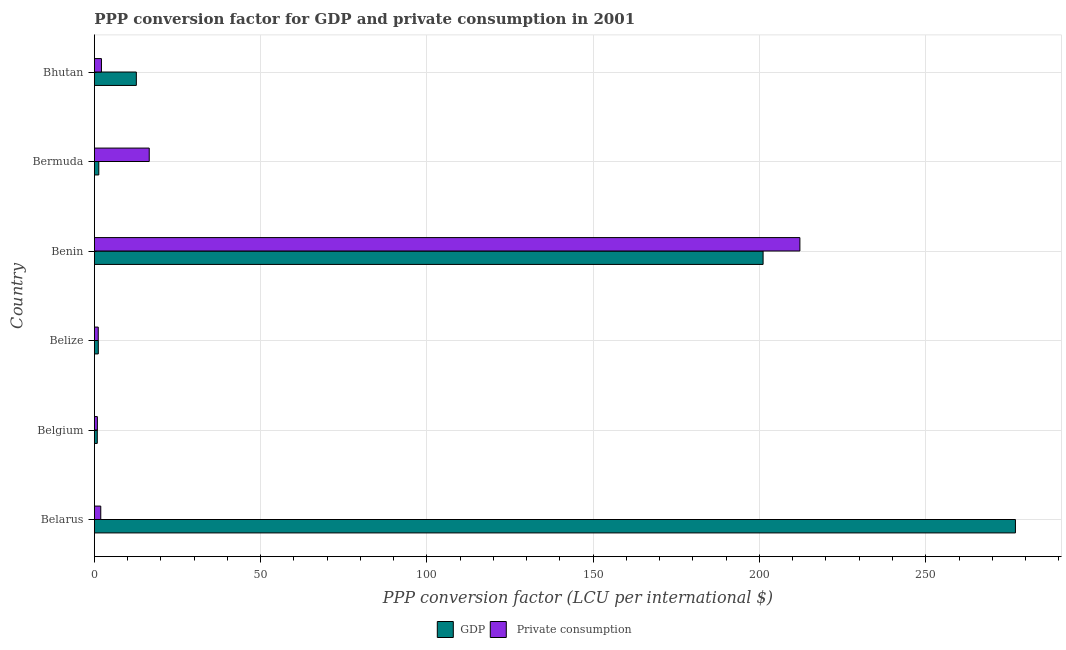How many different coloured bars are there?
Your response must be concise. 2. How many groups of bars are there?
Keep it short and to the point. 6. Are the number of bars on each tick of the Y-axis equal?
Your response must be concise. Yes. In how many cases, is the number of bars for a given country not equal to the number of legend labels?
Your answer should be very brief. 0. What is the ppp conversion factor for gdp in Belize?
Provide a short and direct response. 1.19. Across all countries, what is the maximum ppp conversion factor for gdp?
Make the answer very short. 276.97. Across all countries, what is the minimum ppp conversion factor for gdp?
Give a very brief answer. 0.89. In which country was the ppp conversion factor for gdp maximum?
Ensure brevity in your answer.  Belarus. What is the total ppp conversion factor for gdp in the graph?
Offer a terse response. 494.1. What is the difference between the ppp conversion factor for private consumption in Belarus and that in Belize?
Give a very brief answer. 0.76. What is the difference between the ppp conversion factor for private consumption in Bhutan and the ppp conversion factor for gdp in Belize?
Make the answer very short. 0.95. What is the average ppp conversion factor for private consumption per country?
Make the answer very short. 39.14. What is the difference between the ppp conversion factor for gdp and ppp conversion factor for private consumption in Belize?
Ensure brevity in your answer.  0.01. In how many countries, is the ppp conversion factor for private consumption greater than 140 LCU?
Your answer should be compact. 1. What is the ratio of the ppp conversion factor for private consumption in Belize to that in Bermuda?
Ensure brevity in your answer.  0.07. Is the ppp conversion factor for gdp in Belarus less than that in Benin?
Your response must be concise. No. What is the difference between the highest and the second highest ppp conversion factor for gdp?
Ensure brevity in your answer.  75.88. What is the difference between the highest and the lowest ppp conversion factor for gdp?
Provide a short and direct response. 276.08. What does the 1st bar from the top in Bermuda represents?
Make the answer very short.  Private consumption. What does the 2nd bar from the bottom in Bhutan represents?
Keep it short and to the point.  Private consumption. Are all the bars in the graph horizontal?
Provide a short and direct response. Yes. What is the difference between two consecutive major ticks on the X-axis?
Keep it short and to the point. 50. Are the values on the major ticks of X-axis written in scientific E-notation?
Ensure brevity in your answer.  No. Does the graph contain any zero values?
Your answer should be compact. No. How are the legend labels stacked?
Your response must be concise. Horizontal. What is the title of the graph?
Keep it short and to the point. PPP conversion factor for GDP and private consumption in 2001. Does "GDP" appear as one of the legend labels in the graph?
Provide a succinct answer. Yes. What is the label or title of the X-axis?
Make the answer very short. PPP conversion factor (LCU per international $). What is the PPP conversion factor (LCU per international $) in GDP in Belarus?
Give a very brief answer. 276.97. What is the PPP conversion factor (LCU per international $) in  Private consumption in Belarus?
Provide a succinct answer. 1.93. What is the PPP conversion factor (LCU per international $) in GDP in Belgium?
Provide a succinct answer. 0.89. What is the PPP conversion factor (LCU per international $) of  Private consumption in Belgium?
Make the answer very short. 0.91. What is the PPP conversion factor (LCU per international $) in GDP in Belize?
Your answer should be very brief. 1.19. What is the PPP conversion factor (LCU per international $) of  Private consumption in Belize?
Offer a terse response. 1.17. What is the PPP conversion factor (LCU per international $) in GDP in Benin?
Your answer should be compact. 201.09. What is the PPP conversion factor (LCU per international $) in  Private consumption in Benin?
Your answer should be compact. 212.16. What is the PPP conversion factor (LCU per international $) in GDP in Bermuda?
Give a very brief answer. 1.34. What is the PPP conversion factor (LCU per international $) in  Private consumption in Bermuda?
Give a very brief answer. 16.51. What is the PPP conversion factor (LCU per international $) of GDP in Bhutan?
Ensure brevity in your answer.  12.63. What is the PPP conversion factor (LCU per international $) in  Private consumption in Bhutan?
Ensure brevity in your answer.  2.14. Across all countries, what is the maximum PPP conversion factor (LCU per international $) of GDP?
Keep it short and to the point. 276.97. Across all countries, what is the maximum PPP conversion factor (LCU per international $) of  Private consumption?
Provide a succinct answer. 212.16. Across all countries, what is the minimum PPP conversion factor (LCU per international $) of GDP?
Provide a succinct answer. 0.89. Across all countries, what is the minimum PPP conversion factor (LCU per international $) of  Private consumption?
Provide a short and direct response. 0.91. What is the total PPP conversion factor (LCU per international $) in GDP in the graph?
Ensure brevity in your answer.  494.1. What is the total PPP conversion factor (LCU per international $) in  Private consumption in the graph?
Keep it short and to the point. 234.82. What is the difference between the PPP conversion factor (LCU per international $) in GDP in Belarus and that in Belgium?
Keep it short and to the point. 276.08. What is the difference between the PPP conversion factor (LCU per international $) in  Private consumption in Belarus and that in Belgium?
Offer a terse response. 1.02. What is the difference between the PPP conversion factor (LCU per international $) in GDP in Belarus and that in Belize?
Offer a very short reply. 275.78. What is the difference between the PPP conversion factor (LCU per international $) in  Private consumption in Belarus and that in Belize?
Ensure brevity in your answer.  0.76. What is the difference between the PPP conversion factor (LCU per international $) in GDP in Belarus and that in Benin?
Provide a short and direct response. 75.88. What is the difference between the PPP conversion factor (LCU per international $) in  Private consumption in Belarus and that in Benin?
Your answer should be compact. -210.22. What is the difference between the PPP conversion factor (LCU per international $) of GDP in Belarus and that in Bermuda?
Offer a terse response. 275.63. What is the difference between the PPP conversion factor (LCU per international $) in  Private consumption in Belarus and that in Bermuda?
Keep it short and to the point. -14.57. What is the difference between the PPP conversion factor (LCU per international $) of GDP in Belarus and that in Bhutan?
Your response must be concise. 264.34. What is the difference between the PPP conversion factor (LCU per international $) of  Private consumption in Belarus and that in Bhutan?
Ensure brevity in your answer.  -0.21. What is the difference between the PPP conversion factor (LCU per international $) in GDP in Belgium and that in Belize?
Your response must be concise. -0.3. What is the difference between the PPP conversion factor (LCU per international $) in  Private consumption in Belgium and that in Belize?
Provide a short and direct response. -0.26. What is the difference between the PPP conversion factor (LCU per international $) in GDP in Belgium and that in Benin?
Your answer should be very brief. -200.2. What is the difference between the PPP conversion factor (LCU per international $) in  Private consumption in Belgium and that in Benin?
Your response must be concise. -211.24. What is the difference between the PPP conversion factor (LCU per international $) of GDP in Belgium and that in Bermuda?
Ensure brevity in your answer.  -0.45. What is the difference between the PPP conversion factor (LCU per international $) of  Private consumption in Belgium and that in Bermuda?
Provide a succinct answer. -15.59. What is the difference between the PPP conversion factor (LCU per international $) of GDP in Belgium and that in Bhutan?
Keep it short and to the point. -11.74. What is the difference between the PPP conversion factor (LCU per international $) of  Private consumption in Belgium and that in Bhutan?
Your answer should be compact. -1.23. What is the difference between the PPP conversion factor (LCU per international $) in GDP in Belize and that in Benin?
Offer a very short reply. -199.9. What is the difference between the PPP conversion factor (LCU per international $) of  Private consumption in Belize and that in Benin?
Offer a terse response. -210.98. What is the difference between the PPP conversion factor (LCU per international $) of GDP in Belize and that in Bermuda?
Make the answer very short. -0.15. What is the difference between the PPP conversion factor (LCU per international $) in  Private consumption in Belize and that in Bermuda?
Ensure brevity in your answer.  -15.33. What is the difference between the PPP conversion factor (LCU per international $) in GDP in Belize and that in Bhutan?
Make the answer very short. -11.44. What is the difference between the PPP conversion factor (LCU per international $) in  Private consumption in Belize and that in Bhutan?
Make the answer very short. -0.96. What is the difference between the PPP conversion factor (LCU per international $) of GDP in Benin and that in Bermuda?
Keep it short and to the point. 199.75. What is the difference between the PPP conversion factor (LCU per international $) in  Private consumption in Benin and that in Bermuda?
Provide a succinct answer. 195.65. What is the difference between the PPP conversion factor (LCU per international $) of GDP in Benin and that in Bhutan?
Your response must be concise. 188.46. What is the difference between the PPP conversion factor (LCU per international $) of  Private consumption in Benin and that in Bhutan?
Offer a very short reply. 210.02. What is the difference between the PPP conversion factor (LCU per international $) of GDP in Bermuda and that in Bhutan?
Offer a very short reply. -11.29. What is the difference between the PPP conversion factor (LCU per international $) in  Private consumption in Bermuda and that in Bhutan?
Your answer should be compact. 14.37. What is the difference between the PPP conversion factor (LCU per international $) of GDP in Belarus and the PPP conversion factor (LCU per international $) of  Private consumption in Belgium?
Offer a terse response. 276.05. What is the difference between the PPP conversion factor (LCU per international $) of GDP in Belarus and the PPP conversion factor (LCU per international $) of  Private consumption in Belize?
Provide a short and direct response. 275.79. What is the difference between the PPP conversion factor (LCU per international $) in GDP in Belarus and the PPP conversion factor (LCU per international $) in  Private consumption in Benin?
Your answer should be very brief. 64.81. What is the difference between the PPP conversion factor (LCU per international $) in GDP in Belarus and the PPP conversion factor (LCU per international $) in  Private consumption in Bermuda?
Your response must be concise. 260.46. What is the difference between the PPP conversion factor (LCU per international $) in GDP in Belarus and the PPP conversion factor (LCU per international $) in  Private consumption in Bhutan?
Keep it short and to the point. 274.83. What is the difference between the PPP conversion factor (LCU per international $) in GDP in Belgium and the PPP conversion factor (LCU per international $) in  Private consumption in Belize?
Make the answer very short. -0.29. What is the difference between the PPP conversion factor (LCU per international $) of GDP in Belgium and the PPP conversion factor (LCU per international $) of  Private consumption in Benin?
Offer a very short reply. -211.27. What is the difference between the PPP conversion factor (LCU per international $) in GDP in Belgium and the PPP conversion factor (LCU per international $) in  Private consumption in Bermuda?
Give a very brief answer. -15.62. What is the difference between the PPP conversion factor (LCU per international $) of GDP in Belgium and the PPP conversion factor (LCU per international $) of  Private consumption in Bhutan?
Your answer should be very brief. -1.25. What is the difference between the PPP conversion factor (LCU per international $) of GDP in Belize and the PPP conversion factor (LCU per international $) of  Private consumption in Benin?
Give a very brief answer. -210.97. What is the difference between the PPP conversion factor (LCU per international $) of GDP in Belize and the PPP conversion factor (LCU per international $) of  Private consumption in Bermuda?
Offer a terse response. -15.32. What is the difference between the PPP conversion factor (LCU per international $) of GDP in Belize and the PPP conversion factor (LCU per international $) of  Private consumption in Bhutan?
Keep it short and to the point. -0.95. What is the difference between the PPP conversion factor (LCU per international $) in GDP in Benin and the PPP conversion factor (LCU per international $) in  Private consumption in Bermuda?
Ensure brevity in your answer.  184.58. What is the difference between the PPP conversion factor (LCU per international $) in GDP in Benin and the PPP conversion factor (LCU per international $) in  Private consumption in Bhutan?
Provide a short and direct response. 198.95. What is the difference between the PPP conversion factor (LCU per international $) of GDP in Bermuda and the PPP conversion factor (LCU per international $) of  Private consumption in Bhutan?
Provide a succinct answer. -0.8. What is the average PPP conversion factor (LCU per international $) in GDP per country?
Offer a very short reply. 82.35. What is the average PPP conversion factor (LCU per international $) in  Private consumption per country?
Make the answer very short. 39.14. What is the difference between the PPP conversion factor (LCU per international $) in GDP and PPP conversion factor (LCU per international $) in  Private consumption in Belarus?
Offer a terse response. 275.03. What is the difference between the PPP conversion factor (LCU per international $) of GDP and PPP conversion factor (LCU per international $) of  Private consumption in Belgium?
Offer a terse response. -0.03. What is the difference between the PPP conversion factor (LCU per international $) in GDP and PPP conversion factor (LCU per international $) in  Private consumption in Belize?
Offer a very short reply. 0.02. What is the difference between the PPP conversion factor (LCU per international $) in GDP and PPP conversion factor (LCU per international $) in  Private consumption in Benin?
Offer a terse response. -11.07. What is the difference between the PPP conversion factor (LCU per international $) of GDP and PPP conversion factor (LCU per international $) of  Private consumption in Bermuda?
Make the answer very short. -15.17. What is the difference between the PPP conversion factor (LCU per international $) in GDP and PPP conversion factor (LCU per international $) in  Private consumption in Bhutan?
Provide a succinct answer. 10.49. What is the ratio of the PPP conversion factor (LCU per international $) in GDP in Belarus to that in Belgium?
Your answer should be compact. 312.9. What is the ratio of the PPP conversion factor (LCU per international $) in  Private consumption in Belarus to that in Belgium?
Give a very brief answer. 2.12. What is the ratio of the PPP conversion factor (LCU per international $) in GDP in Belarus to that in Belize?
Make the answer very short. 232.79. What is the ratio of the PPP conversion factor (LCU per international $) of  Private consumption in Belarus to that in Belize?
Give a very brief answer. 1.65. What is the ratio of the PPP conversion factor (LCU per international $) in GDP in Belarus to that in Benin?
Keep it short and to the point. 1.38. What is the ratio of the PPP conversion factor (LCU per international $) in  Private consumption in Belarus to that in Benin?
Offer a very short reply. 0.01. What is the ratio of the PPP conversion factor (LCU per international $) in GDP in Belarus to that in Bermuda?
Your answer should be very brief. 206.85. What is the ratio of the PPP conversion factor (LCU per international $) of  Private consumption in Belarus to that in Bermuda?
Your answer should be compact. 0.12. What is the ratio of the PPP conversion factor (LCU per international $) in GDP in Belarus to that in Bhutan?
Offer a very short reply. 21.93. What is the ratio of the PPP conversion factor (LCU per international $) in  Private consumption in Belarus to that in Bhutan?
Make the answer very short. 0.9. What is the ratio of the PPP conversion factor (LCU per international $) of GDP in Belgium to that in Belize?
Give a very brief answer. 0.74. What is the ratio of the PPP conversion factor (LCU per international $) in  Private consumption in Belgium to that in Belize?
Make the answer very short. 0.78. What is the ratio of the PPP conversion factor (LCU per international $) in GDP in Belgium to that in Benin?
Offer a terse response. 0. What is the ratio of the PPP conversion factor (LCU per international $) of  Private consumption in Belgium to that in Benin?
Ensure brevity in your answer.  0. What is the ratio of the PPP conversion factor (LCU per international $) in GDP in Belgium to that in Bermuda?
Your answer should be compact. 0.66. What is the ratio of the PPP conversion factor (LCU per international $) of  Private consumption in Belgium to that in Bermuda?
Your answer should be very brief. 0.06. What is the ratio of the PPP conversion factor (LCU per international $) in GDP in Belgium to that in Bhutan?
Your answer should be compact. 0.07. What is the ratio of the PPP conversion factor (LCU per international $) of  Private consumption in Belgium to that in Bhutan?
Give a very brief answer. 0.43. What is the ratio of the PPP conversion factor (LCU per international $) in GDP in Belize to that in Benin?
Your answer should be very brief. 0.01. What is the ratio of the PPP conversion factor (LCU per international $) of  Private consumption in Belize to that in Benin?
Your answer should be compact. 0.01. What is the ratio of the PPP conversion factor (LCU per international $) of GDP in Belize to that in Bermuda?
Offer a terse response. 0.89. What is the ratio of the PPP conversion factor (LCU per international $) of  Private consumption in Belize to that in Bermuda?
Your response must be concise. 0.07. What is the ratio of the PPP conversion factor (LCU per international $) of GDP in Belize to that in Bhutan?
Offer a very short reply. 0.09. What is the ratio of the PPP conversion factor (LCU per international $) in  Private consumption in Belize to that in Bhutan?
Make the answer very short. 0.55. What is the ratio of the PPP conversion factor (LCU per international $) of GDP in Benin to that in Bermuda?
Make the answer very short. 150.18. What is the ratio of the PPP conversion factor (LCU per international $) in  Private consumption in Benin to that in Bermuda?
Provide a short and direct response. 12.85. What is the ratio of the PPP conversion factor (LCU per international $) of GDP in Benin to that in Bhutan?
Provide a succinct answer. 15.92. What is the ratio of the PPP conversion factor (LCU per international $) in  Private consumption in Benin to that in Bhutan?
Make the answer very short. 99.18. What is the ratio of the PPP conversion factor (LCU per international $) in GDP in Bermuda to that in Bhutan?
Offer a terse response. 0.11. What is the ratio of the PPP conversion factor (LCU per international $) in  Private consumption in Bermuda to that in Bhutan?
Provide a succinct answer. 7.72. What is the difference between the highest and the second highest PPP conversion factor (LCU per international $) of GDP?
Provide a short and direct response. 75.88. What is the difference between the highest and the second highest PPP conversion factor (LCU per international $) of  Private consumption?
Keep it short and to the point. 195.65. What is the difference between the highest and the lowest PPP conversion factor (LCU per international $) of GDP?
Keep it short and to the point. 276.08. What is the difference between the highest and the lowest PPP conversion factor (LCU per international $) of  Private consumption?
Provide a short and direct response. 211.24. 